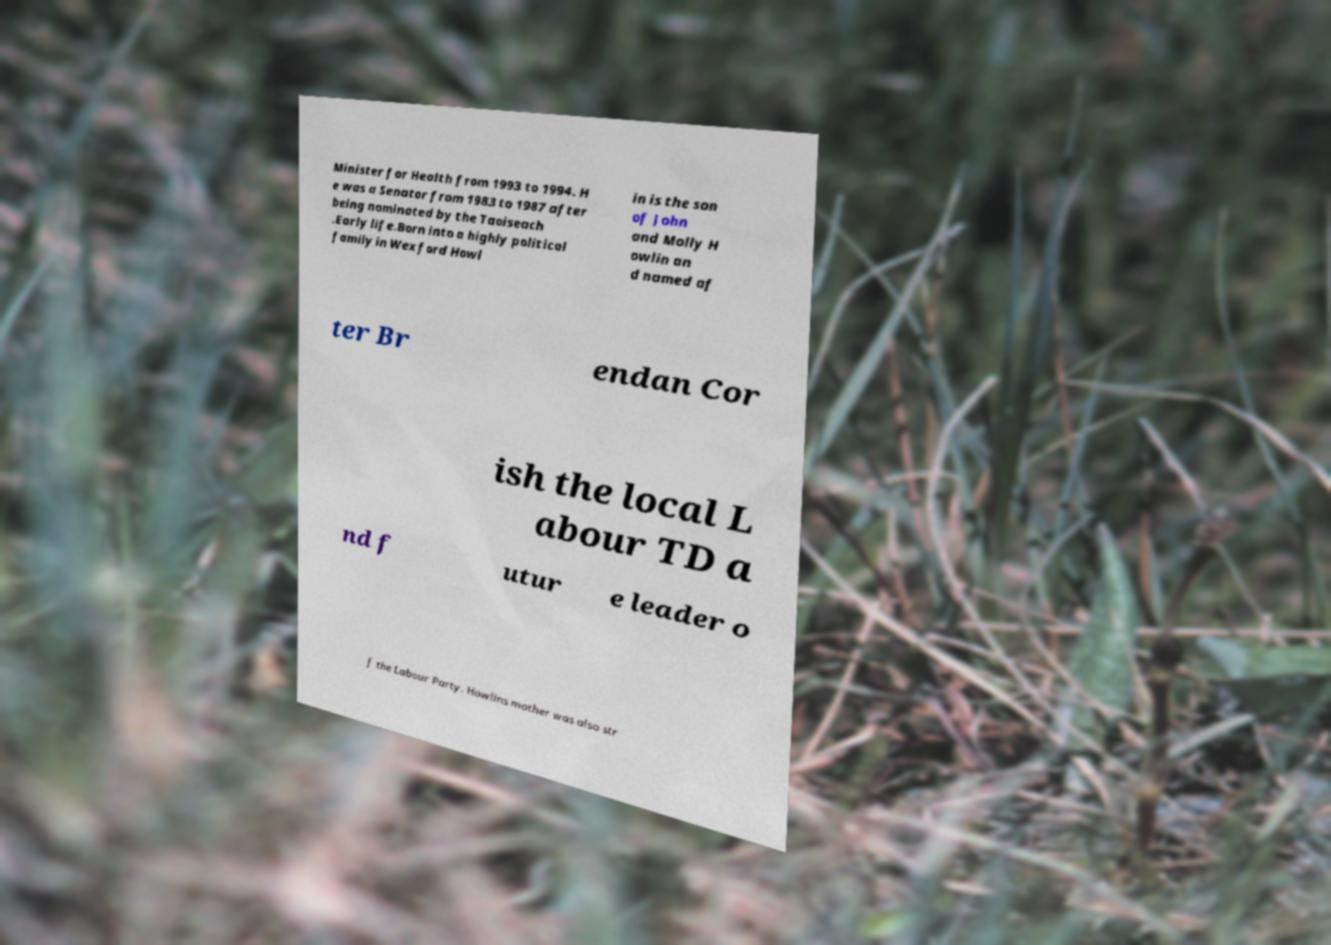Could you extract and type out the text from this image? Minister for Health from 1993 to 1994. H e was a Senator from 1983 to 1987 after being nominated by the Taoiseach .Early life.Born into a highly political family in Wexford Howl in is the son of John and Molly H owlin an d named af ter Br endan Cor ish the local L abour TD a nd f utur e leader o f the Labour Party. Howlins mother was also str 